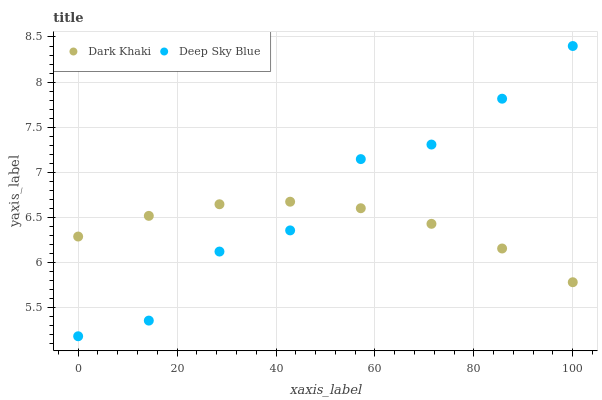Does Dark Khaki have the minimum area under the curve?
Answer yes or no. Yes. Does Deep Sky Blue have the maximum area under the curve?
Answer yes or no. Yes. Does Deep Sky Blue have the minimum area under the curve?
Answer yes or no. No. Is Dark Khaki the smoothest?
Answer yes or no. Yes. Is Deep Sky Blue the roughest?
Answer yes or no. Yes. Is Deep Sky Blue the smoothest?
Answer yes or no. No. Does Deep Sky Blue have the lowest value?
Answer yes or no. Yes. Does Deep Sky Blue have the highest value?
Answer yes or no. Yes. Does Dark Khaki intersect Deep Sky Blue?
Answer yes or no. Yes. Is Dark Khaki less than Deep Sky Blue?
Answer yes or no. No. Is Dark Khaki greater than Deep Sky Blue?
Answer yes or no. No. 